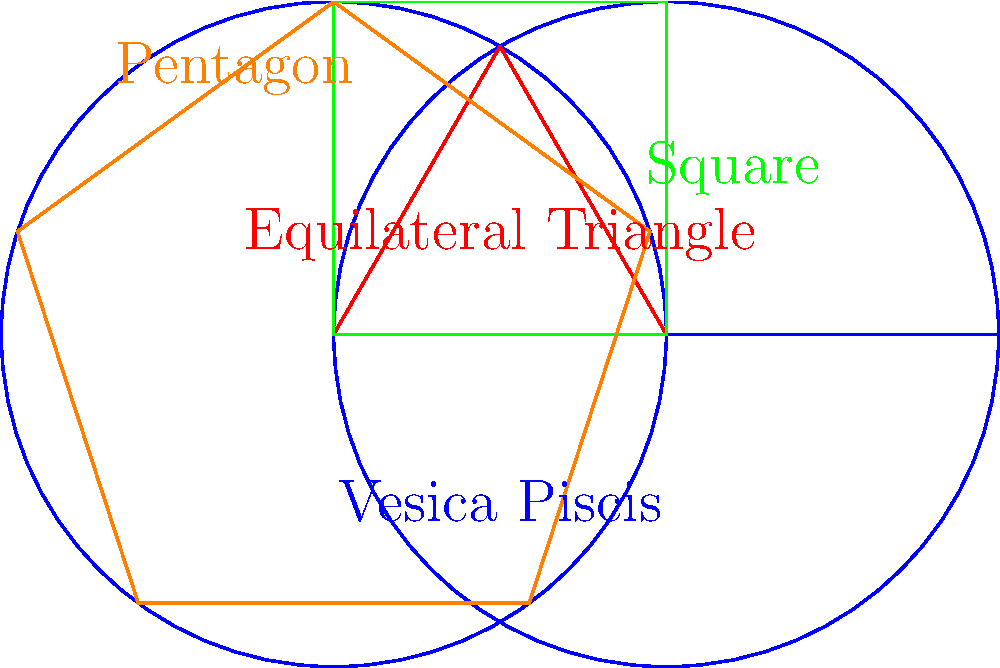In the context of sacred geometry, which of the shapes shown above is most closely associated with the concept of divine proportion and is often found in the architectural designs of medieval cathedrals? To answer this question, let's examine each shape and its significance in sacred geometry:

1. Vesica Piscis (blue):
   - Formed by the intersection of two equal-sized circles
   - Symbolizes the creation of the universe in many traditions
   - Important in Christian symbolism but not directly related to divine proportion

2. Equilateral Triangle (red):
   - Represents the Trinity in Christian symbolism
   - Important in sacred geometry but not specifically tied to divine proportion

3. Square (green):
   - Represents stability and the physical world
   - Not directly associated with divine proportion

4. Pentagon (orange):
   - Connected to the golden ratio through its relationship with the pentagram
   - The ratio of its diagonal to its side is the golden ratio (φ ≈ 1.618)
   - Often found in the architectural designs of medieval cathedrals
   - Closely associated with the concept of divine proportion

The golden ratio, also known as the divine proportion, is approximately 1.618 and is denoted by the Greek letter φ (phi). It's considered aesthetically pleasing and has been used in art and architecture for centuries.

Of the shapes shown, the pentagon is most closely associated with the divine proportion. The relationship between a pentagon's side and its diagonal is exactly the golden ratio. This proportion was often incorporated into the design of medieval cathedrals, as it was believed to reflect divine harmony and beauty.

Medieval cathedral architects and artists frequently used the golden ratio in their designs, incorporating pentagons and five-pointed stars (pentagrams) in floor plans, window designs, and other architectural elements. This was done to imbue the structures with what was perceived as divine mathematical harmony.
Answer: Pentagon 